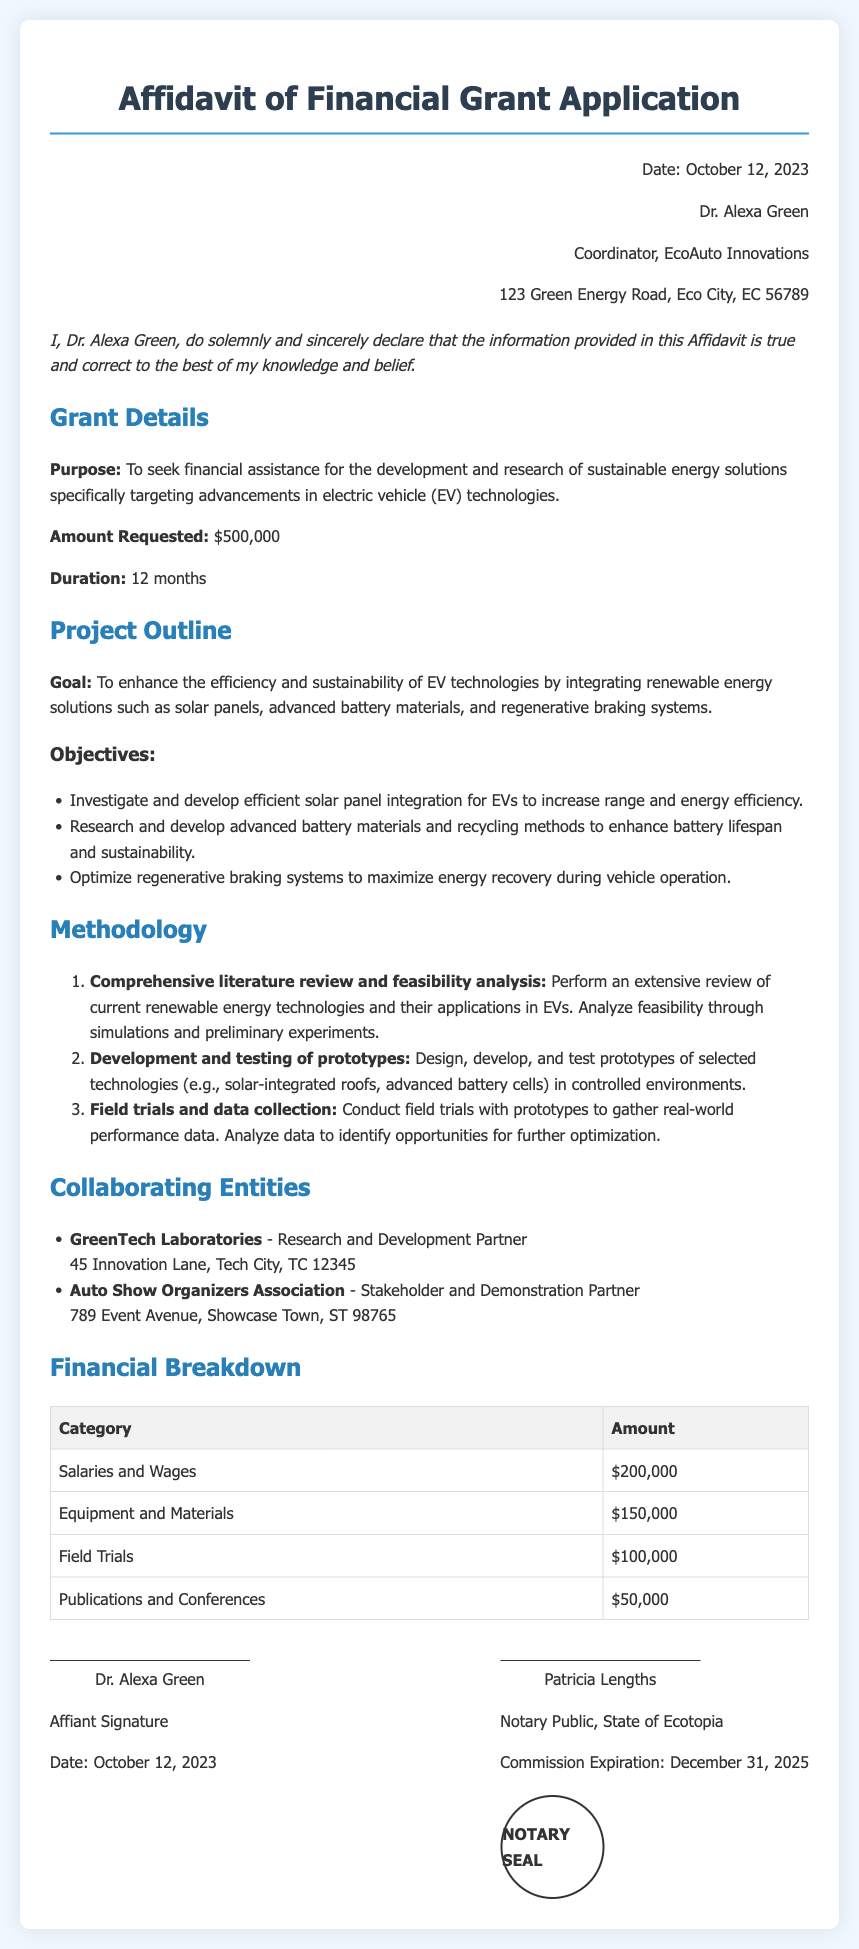What is the purpose of the grant? The purpose is clearly stated in the document as seeking financial assistance for the development and research of sustainable energy solutions specifically targeting advancements in electric vehicle technologies.
Answer: Development and research of sustainable energy solutions for electric vehicle technologies What is the amount requested? The document specifies the financial assistance amount being requested for the project.
Answer: $500,000 How long is the project duration? The duration of the project is mentioned in the document under the grant details section.
Answer: 12 months Who is the affiant? The document identifies the individual making the declaration of truth, which is essential in an affidavit.
Answer: Dr. Alexa Green Which entity is listed as the research and development partner? The document names a specific organization that collaborates on the project for research and development activities.
Answer: GreenTech Laboratories What are the first two objectives listed under Project Outline? The objectives are specifically enumerated in a list, making it easy to retrieve the first two mentioned.
Answer: Investigate and develop efficient solar panel integration for EVs to increase range and energy efficiency, Research and develop advanced battery materials and recycling methods to enhance battery lifespan and sustainability What is the total amount allocated for salaries and wages? The financial breakdown section specifies this category’s amount, which contributes to understanding the budget allocation in the project.
Answer: $200,000 Who is the Notary Public for this affidavit? The identity of the notary public is given with their name, which is important for validating the affidavit's authenticity.
Answer: Patricia Lengths When did the affidavit get signed? The date provided in the signature section is crucial for understanding the timeline related to the affidavit.
Answer: October 12, 2023 